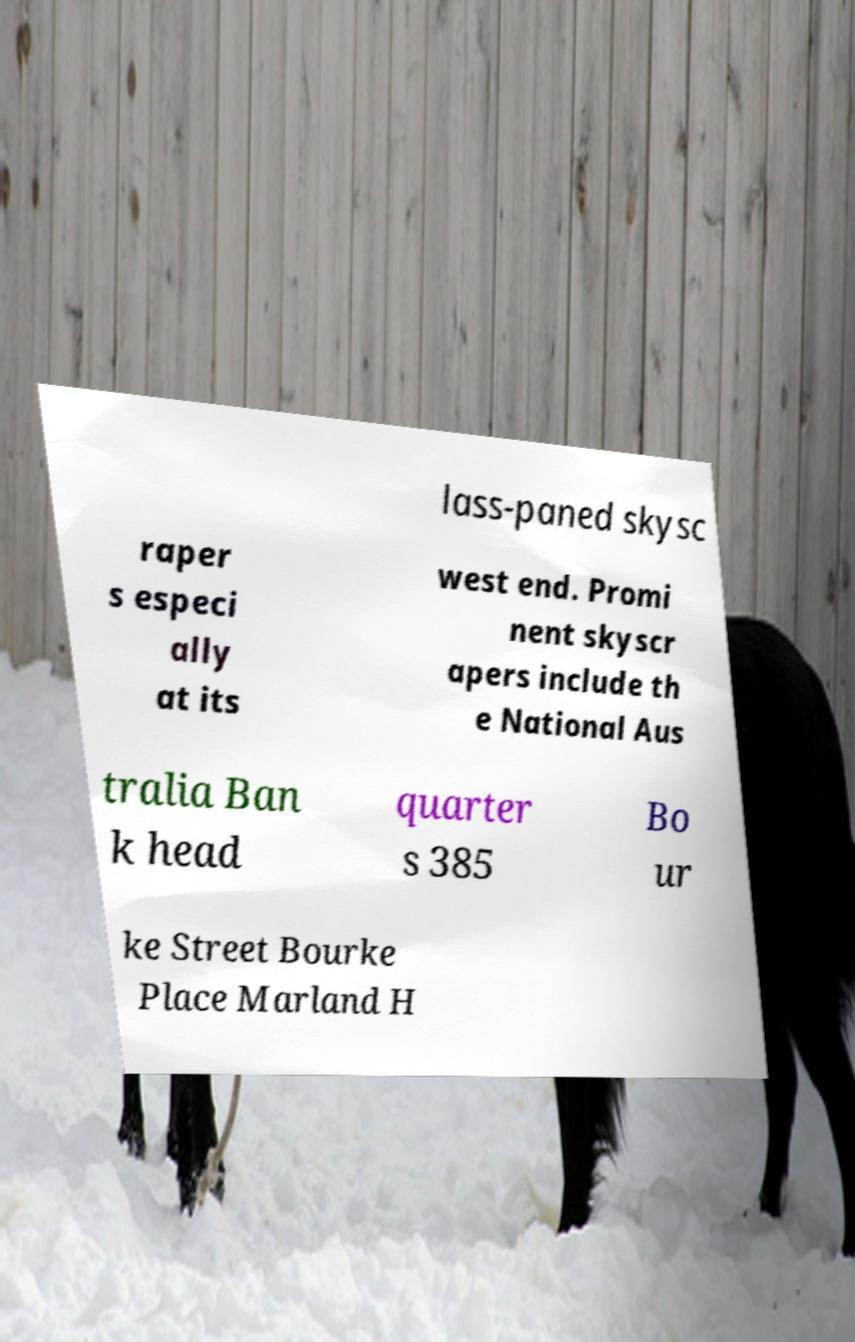Please identify and transcribe the text found in this image. lass-paned skysc raper s especi ally at its west end. Promi nent skyscr apers include th e National Aus tralia Ban k head quarter s 385 Bo ur ke Street Bourke Place Marland H 